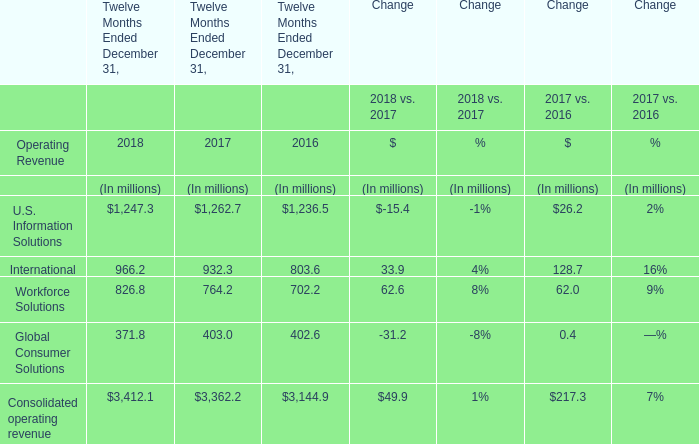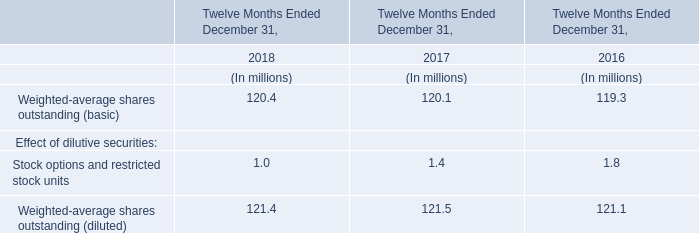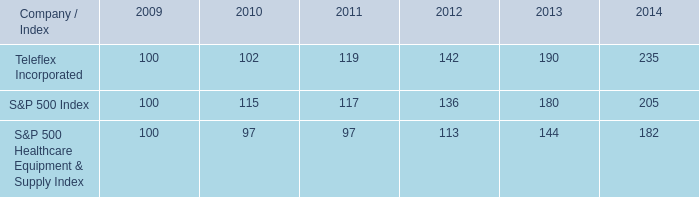Does U.S. Information Solutions keeps increasing each year between 2016 and 2018? 
Answer: no. 